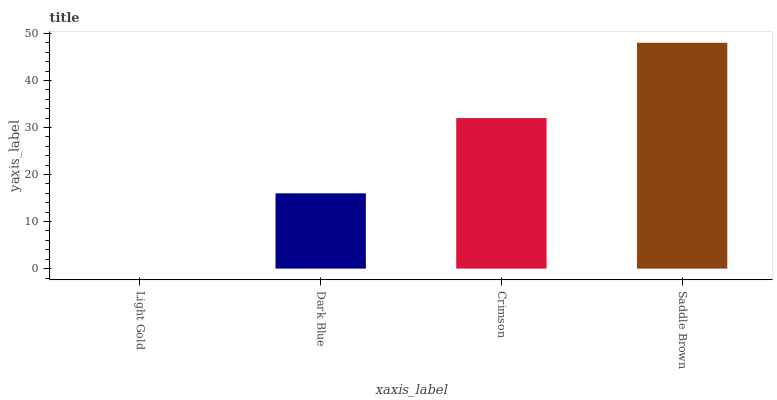Is Light Gold the minimum?
Answer yes or no. Yes. Is Saddle Brown the maximum?
Answer yes or no. Yes. Is Dark Blue the minimum?
Answer yes or no. No. Is Dark Blue the maximum?
Answer yes or no. No. Is Dark Blue greater than Light Gold?
Answer yes or no. Yes. Is Light Gold less than Dark Blue?
Answer yes or no. Yes. Is Light Gold greater than Dark Blue?
Answer yes or no. No. Is Dark Blue less than Light Gold?
Answer yes or no. No. Is Crimson the high median?
Answer yes or no. Yes. Is Dark Blue the low median?
Answer yes or no. Yes. Is Dark Blue the high median?
Answer yes or no. No. Is Light Gold the low median?
Answer yes or no. No. 